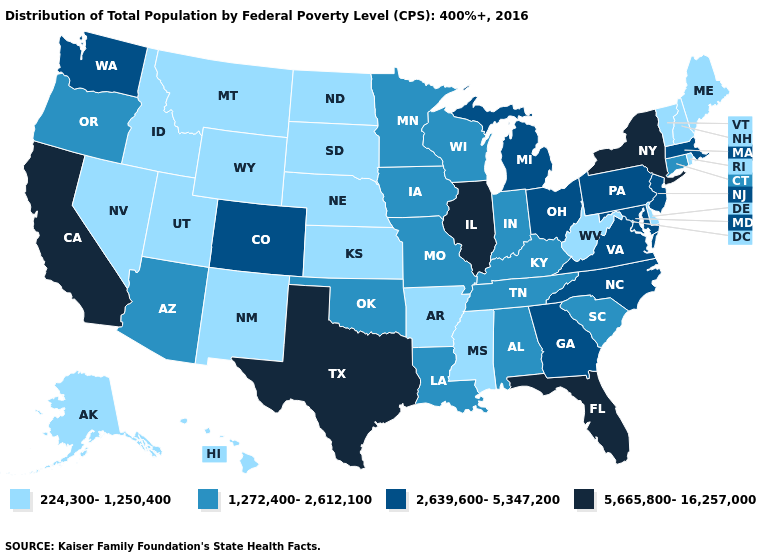Name the states that have a value in the range 1,272,400-2,612,100?
Be succinct. Alabama, Arizona, Connecticut, Indiana, Iowa, Kentucky, Louisiana, Minnesota, Missouri, Oklahoma, Oregon, South Carolina, Tennessee, Wisconsin. Does California have the highest value in the USA?
Write a very short answer. Yes. Among the states that border Kentucky , does West Virginia have the lowest value?
Answer briefly. Yes. Name the states that have a value in the range 224,300-1,250,400?
Concise answer only. Alaska, Arkansas, Delaware, Hawaii, Idaho, Kansas, Maine, Mississippi, Montana, Nebraska, Nevada, New Hampshire, New Mexico, North Dakota, Rhode Island, South Dakota, Utah, Vermont, West Virginia, Wyoming. What is the lowest value in the USA?
Write a very short answer. 224,300-1,250,400. What is the value of South Dakota?
Quick response, please. 224,300-1,250,400. What is the value of Maine?
Be succinct. 224,300-1,250,400. Name the states that have a value in the range 1,272,400-2,612,100?
Keep it brief. Alabama, Arizona, Connecticut, Indiana, Iowa, Kentucky, Louisiana, Minnesota, Missouri, Oklahoma, Oregon, South Carolina, Tennessee, Wisconsin. Among the states that border Tennessee , which have the lowest value?
Write a very short answer. Arkansas, Mississippi. Does New Mexico have the lowest value in the USA?
Concise answer only. Yes. Name the states that have a value in the range 2,639,600-5,347,200?
Quick response, please. Colorado, Georgia, Maryland, Massachusetts, Michigan, New Jersey, North Carolina, Ohio, Pennsylvania, Virginia, Washington. What is the value of Wyoming?
Short answer required. 224,300-1,250,400. What is the value of New Mexico?
Short answer required. 224,300-1,250,400. Among the states that border Arizona , which have the lowest value?
Concise answer only. Nevada, New Mexico, Utah. Name the states that have a value in the range 2,639,600-5,347,200?
Concise answer only. Colorado, Georgia, Maryland, Massachusetts, Michigan, New Jersey, North Carolina, Ohio, Pennsylvania, Virginia, Washington. 